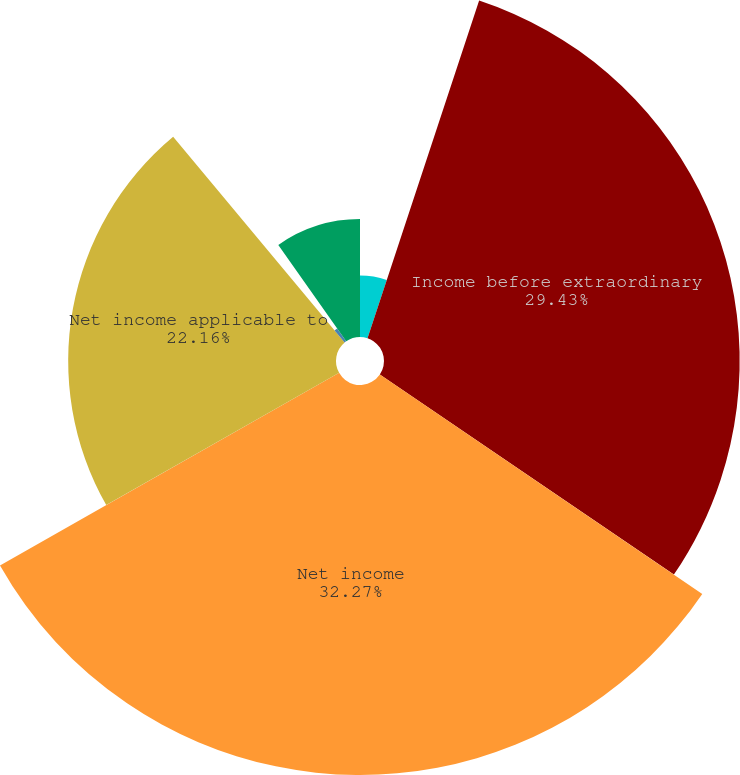Convert chart. <chart><loc_0><loc_0><loc_500><loc_500><pie_chart><fcel>amounts)<fcel>Income before extraordinary<fcel>Net income<fcel>Net income applicable to<fcel>Less Dividends and<fcel>Total weighted-average basic<nl><fcel>5.08%<fcel>29.43%<fcel>32.27%<fcel>22.16%<fcel>1.3%<fcel>9.76%<nl></chart> 